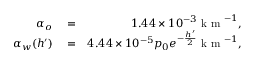<formula> <loc_0><loc_0><loc_500><loc_500>\begin{array} { r l r } { \alpha _ { o } } & = } & { 1 . 4 4 \times 1 0 ^ { - 3 } k m ^ { - 1 } , } \\ { \alpha _ { w } ( h ^ { \prime } ) } & = } & { 4 . 4 4 \times 1 0 ^ { - 5 } p _ { 0 } e ^ { - \frac { h ^ { \prime } } { 2 } } k m ^ { - 1 } , } \end{array}</formula> 